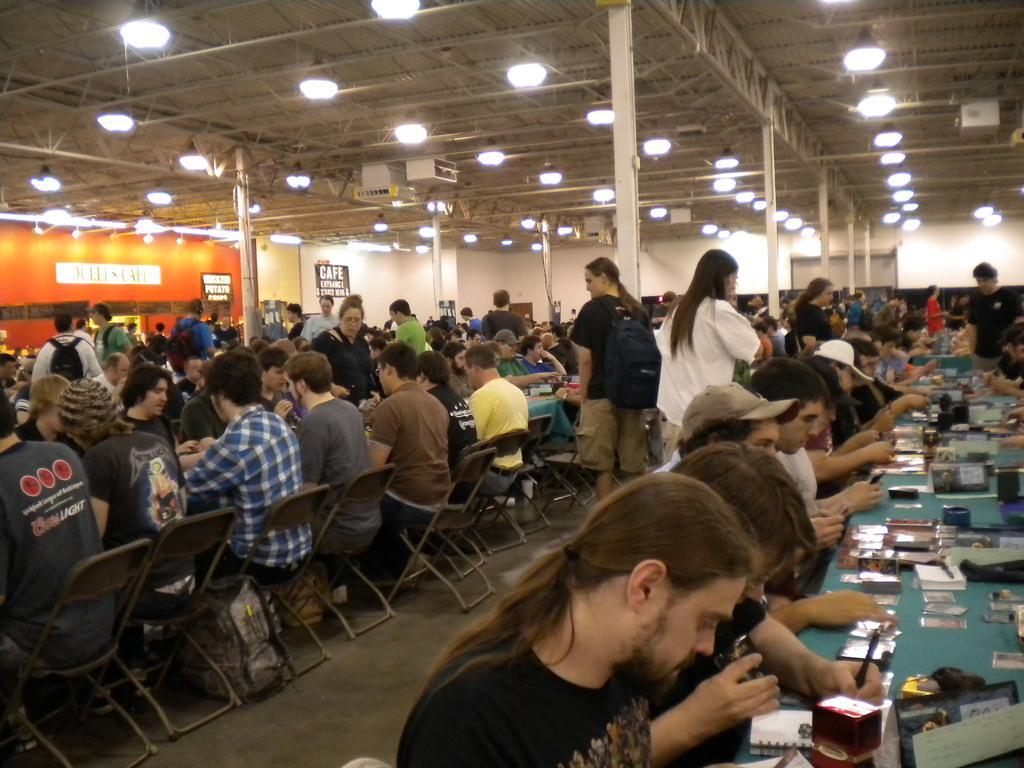How would you summarize this image in a sentence or two? In this picture we can see a group of people sitting on chairs and in front of them on table we have books, boxes and some are standing looking at them and in the background we can see wall, poster, lights, pillar. 